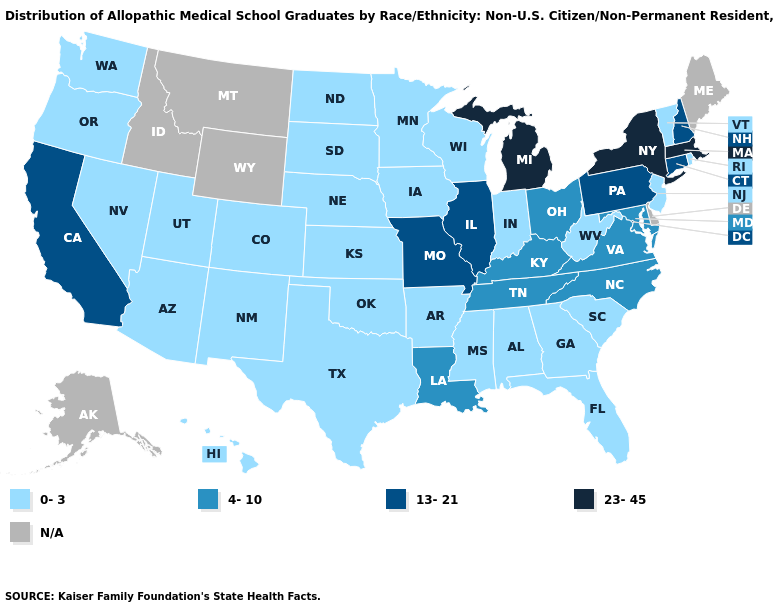Name the states that have a value in the range 23-45?
Concise answer only. Massachusetts, Michigan, New York. What is the value of Mississippi?
Answer briefly. 0-3. What is the lowest value in states that border South Carolina?
Answer briefly. 0-3. What is the highest value in states that border Georgia?
Quick response, please. 4-10. What is the lowest value in states that border Alabama?
Answer briefly. 0-3. What is the lowest value in the MidWest?
Quick response, please. 0-3. What is the highest value in the West ?
Give a very brief answer. 13-21. Does the first symbol in the legend represent the smallest category?
Concise answer only. Yes. What is the value of Oklahoma?
Concise answer only. 0-3. Does Connecticut have the lowest value in the USA?
Answer briefly. No. Which states have the lowest value in the USA?
Write a very short answer. Alabama, Arizona, Arkansas, Colorado, Florida, Georgia, Hawaii, Indiana, Iowa, Kansas, Minnesota, Mississippi, Nebraska, Nevada, New Jersey, New Mexico, North Dakota, Oklahoma, Oregon, Rhode Island, South Carolina, South Dakota, Texas, Utah, Vermont, Washington, West Virginia, Wisconsin. What is the highest value in the West ?
Answer briefly. 13-21. What is the value of Oklahoma?
Short answer required. 0-3. 